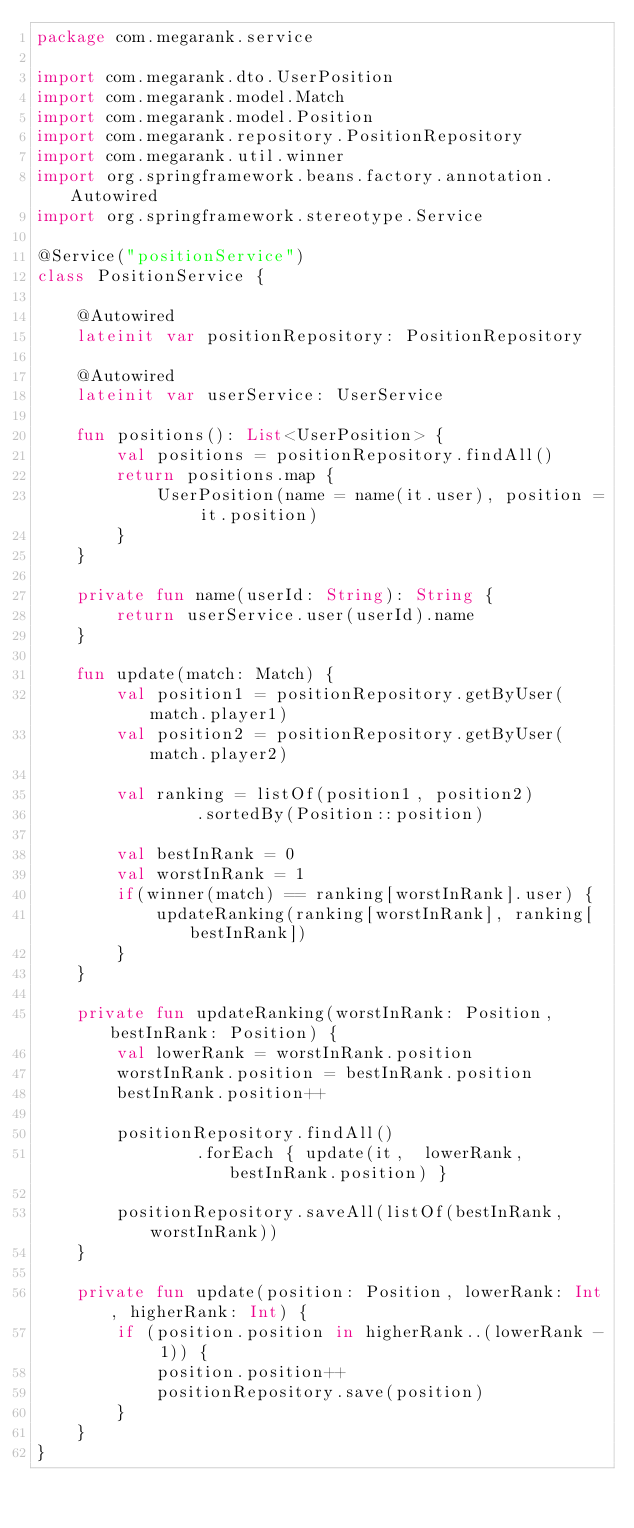Convert code to text. <code><loc_0><loc_0><loc_500><loc_500><_Kotlin_>package com.megarank.service

import com.megarank.dto.UserPosition
import com.megarank.model.Match
import com.megarank.model.Position
import com.megarank.repository.PositionRepository
import com.megarank.util.winner
import org.springframework.beans.factory.annotation.Autowired
import org.springframework.stereotype.Service

@Service("positionService")
class PositionService {

    @Autowired
    lateinit var positionRepository: PositionRepository

    @Autowired
    lateinit var userService: UserService

    fun positions(): List<UserPosition> {
        val positions = positionRepository.findAll()
        return positions.map {
            UserPosition(name = name(it.user), position = it.position)
        }
    }

    private fun name(userId: String): String {
        return userService.user(userId).name
    }

    fun update(match: Match) {
        val position1 = positionRepository.getByUser(match.player1)
        val position2 = positionRepository.getByUser(match.player2)

        val ranking = listOf(position1, position2)
                .sortedBy(Position::position)

        val bestInRank = 0
        val worstInRank = 1
        if(winner(match) == ranking[worstInRank].user) {
            updateRanking(ranking[worstInRank], ranking[bestInRank])
        }
    }

    private fun updateRanking(worstInRank: Position, bestInRank: Position) {
        val lowerRank = worstInRank.position
        worstInRank.position = bestInRank.position
        bestInRank.position++

        positionRepository.findAll()
                .forEach { update(it,  lowerRank, bestInRank.position) }

        positionRepository.saveAll(listOf(bestInRank, worstInRank))
    }

    private fun update(position: Position, lowerRank: Int, higherRank: Int) {
        if (position.position in higherRank..(lowerRank - 1)) {
            position.position++
            positionRepository.save(position)
        }
    }
}</code> 